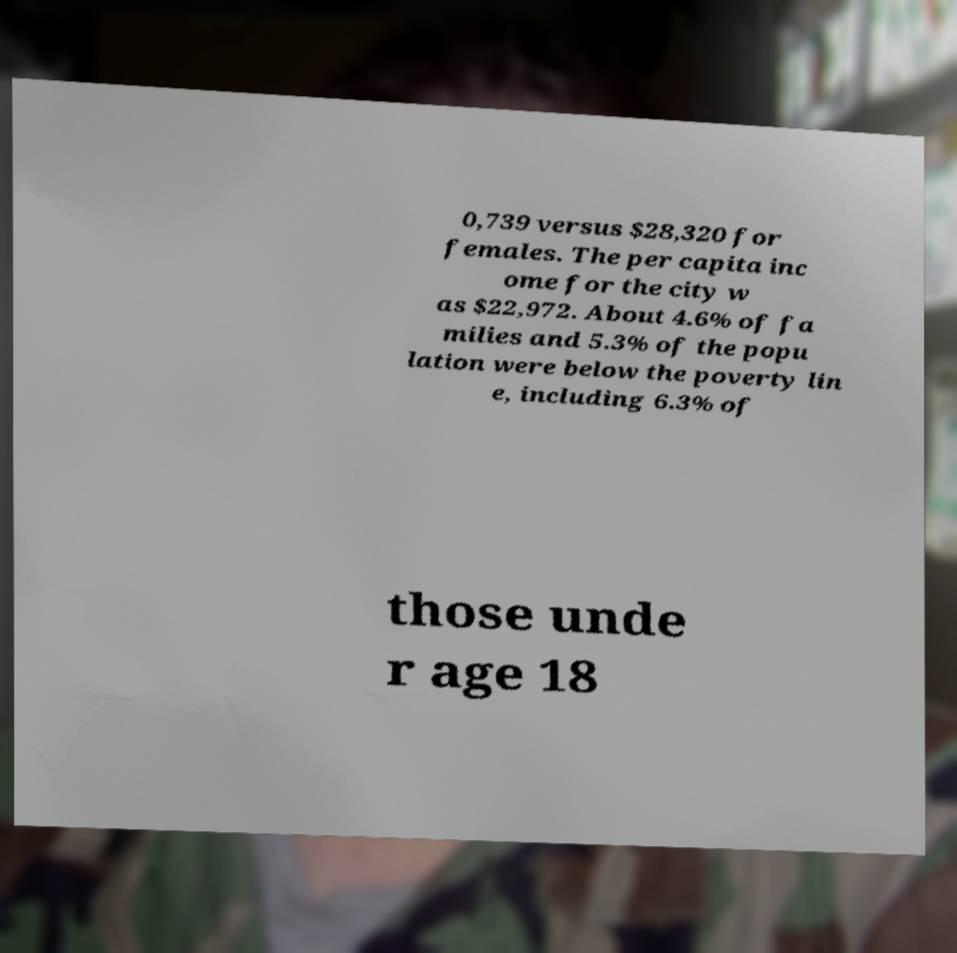Could you assist in decoding the text presented in this image and type it out clearly? 0,739 versus $28,320 for females. The per capita inc ome for the city w as $22,972. About 4.6% of fa milies and 5.3% of the popu lation were below the poverty lin e, including 6.3% of those unde r age 18 